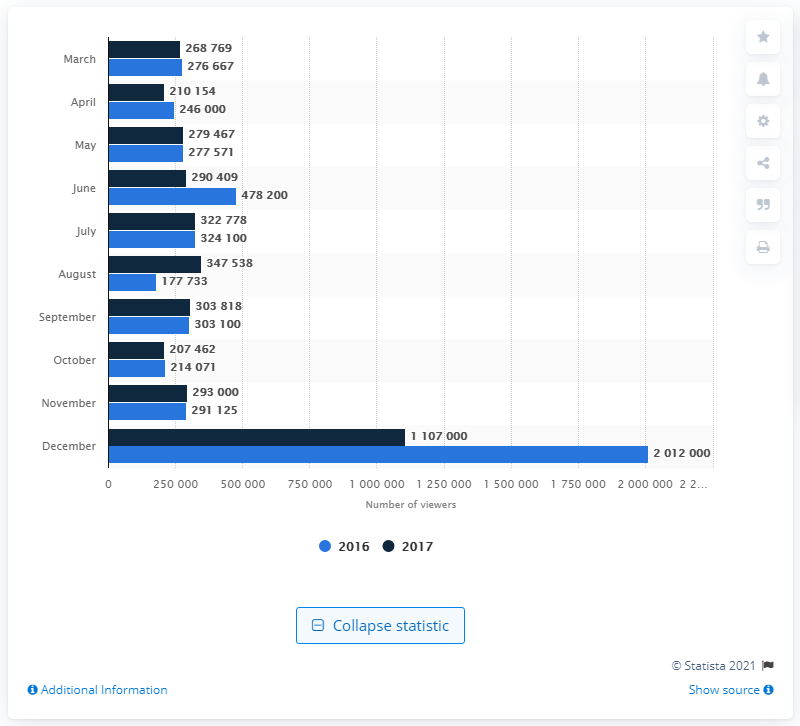Identify some key points in this picture. In June 2017, a total of 478,200 people watched a Major League Soccer game. In June 2017, a total of 290,409 individuals viewed a Major League Soccer game. 